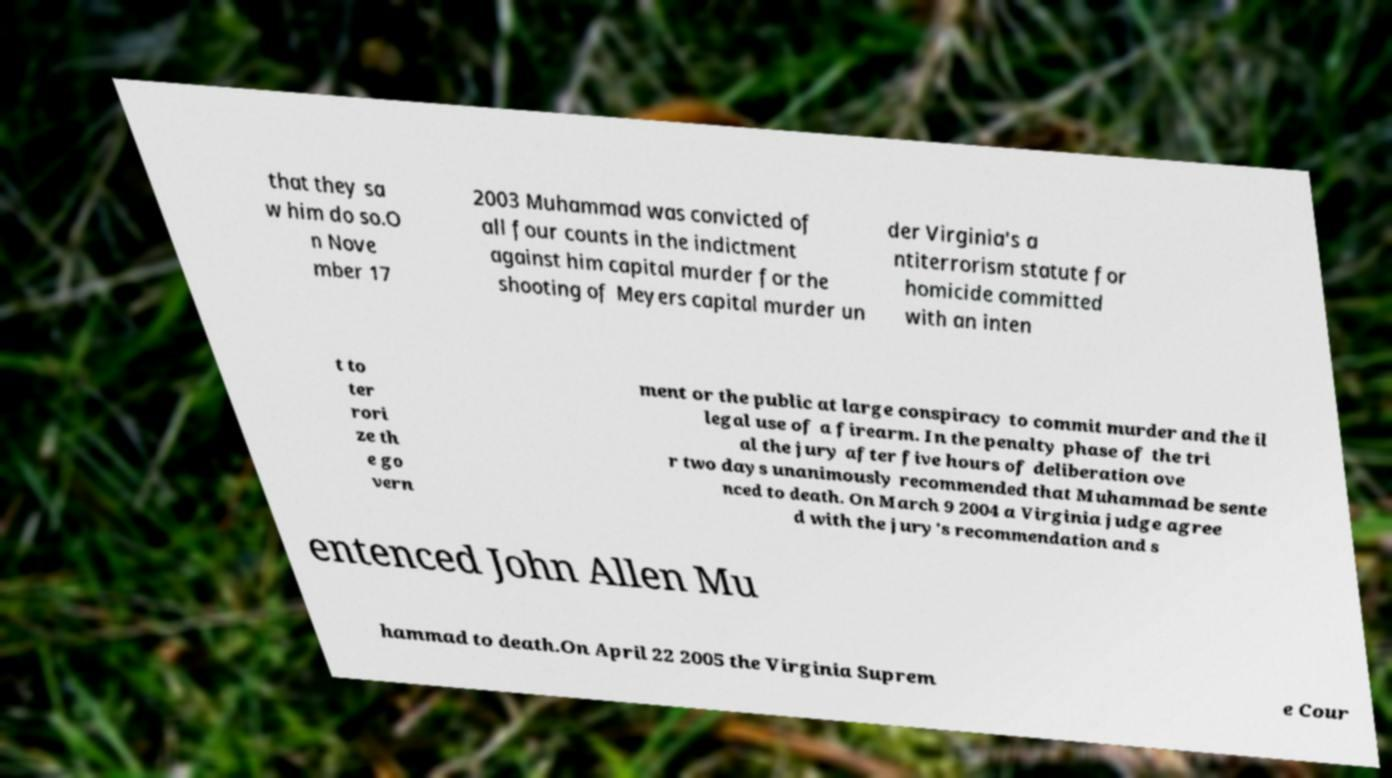For documentation purposes, I need the text within this image transcribed. Could you provide that? that they sa w him do so.O n Nove mber 17 2003 Muhammad was convicted of all four counts in the indictment against him capital murder for the shooting of Meyers capital murder un der Virginia's a ntiterrorism statute for homicide committed with an inten t to ter rori ze th e go vern ment or the public at large conspiracy to commit murder and the il legal use of a firearm. In the penalty phase of the tri al the jury after five hours of deliberation ove r two days unanimously recommended that Muhammad be sente nced to death. On March 9 2004 a Virginia judge agree d with the jury's recommendation and s entenced John Allen Mu hammad to death.On April 22 2005 the Virginia Suprem e Cour 